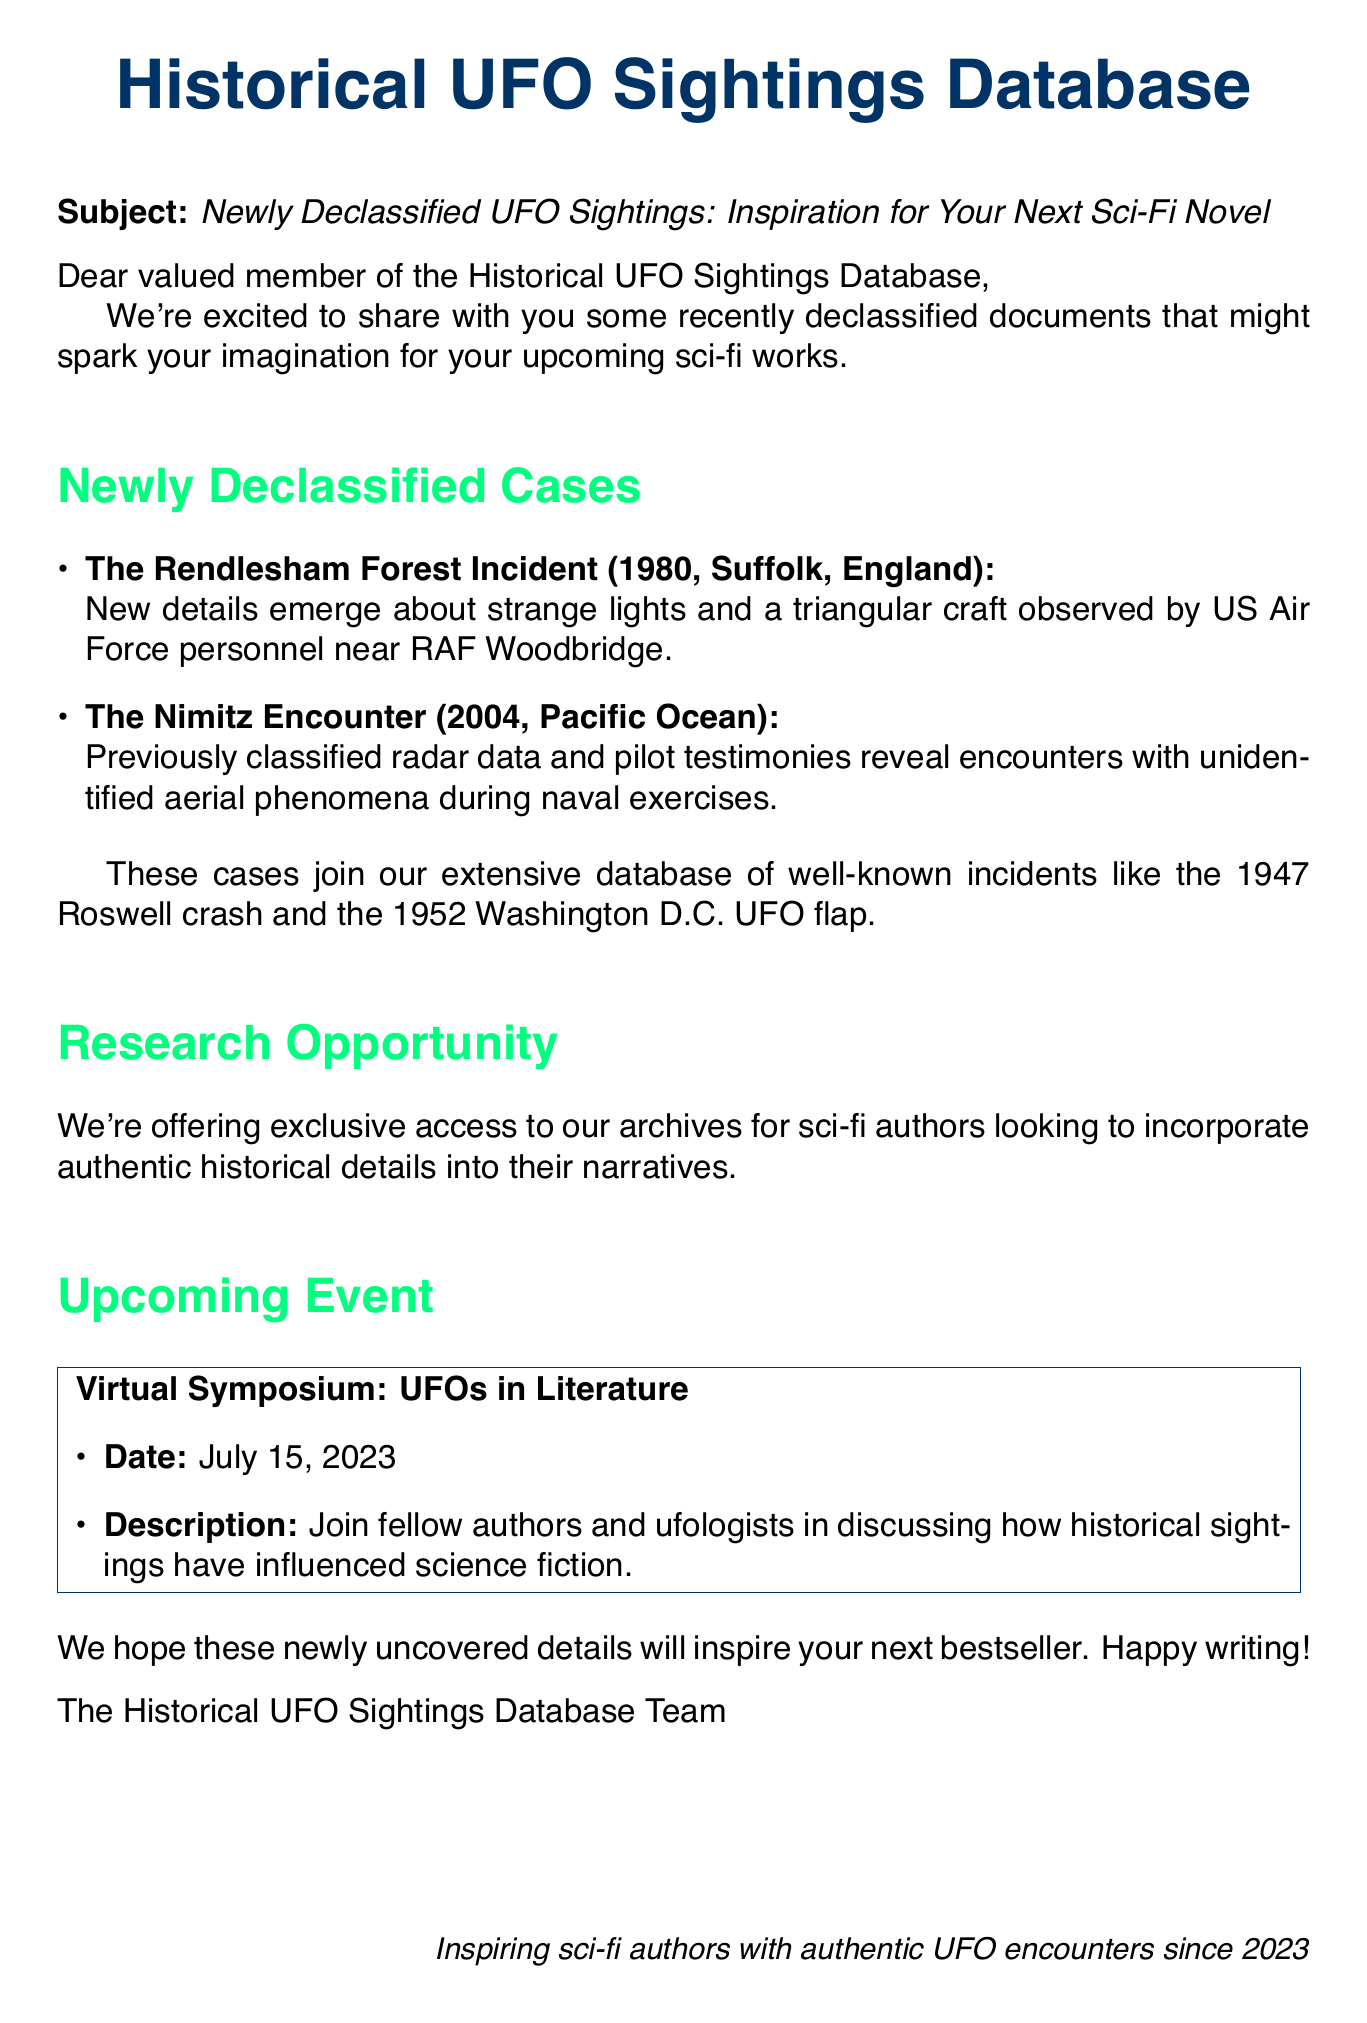What is the subject of the email? The subject of the email is found in the document's subject line, which introduces the content of the newsletter.
Answer: Newly Declassified UFO Sightings: Inspiration for Your Next Sci-Fi Novel What year did the Rendlesham Forest Incident occur? The year of the Rendlesham Forest Incident is mentioned in the description of this case within the document.
Answer: 1980 Where did the Nimitz Encounter take place? The location of the Nimitz Encounter is specified in the description provided in the document.
Answer: Pacific Ocean What is the date of the upcoming event? The event's date is clearly stated in the section dedicated to the upcoming event within the document.
Answer: July 15, 2023 Which incident occurred in England? The location of the incident is mentioned within the details of the newly declassified cases, specifying where it happened.
Answer: The Rendlesham Forest Incident What type of opportunity is offered to sci-fi authors? The offered opportunity is detailed in the document as it relates to access to archives for writing.
Answer: Exclusive access to archives Who is the intended audience of this newsletter? The closing greeting indicates whom the message is addressing, reflecting the audience for the newsletter.
Answer: Valued member of the Historical UFO Sightings Database What does the upcoming event focus on? The description under the upcoming event section explains the main topic of discussion at the symposium.
Answer: How historical sightings have influenced science fiction 